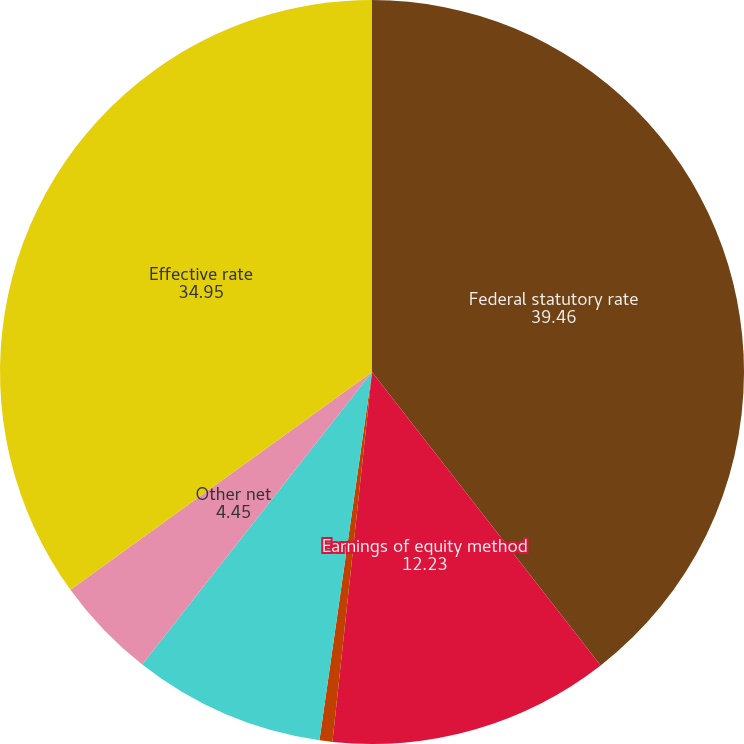Convert chart to OTSL. <chart><loc_0><loc_0><loc_500><loc_500><pie_chart><fcel>Federal statutory rate<fcel>Earnings of equity method<fcel>State taxes net of federal<fcel>Difference between US and<fcel>Other net<fcel>Effective rate<nl><fcel>39.46%<fcel>12.23%<fcel>0.56%<fcel>8.34%<fcel>4.45%<fcel>34.95%<nl></chart> 